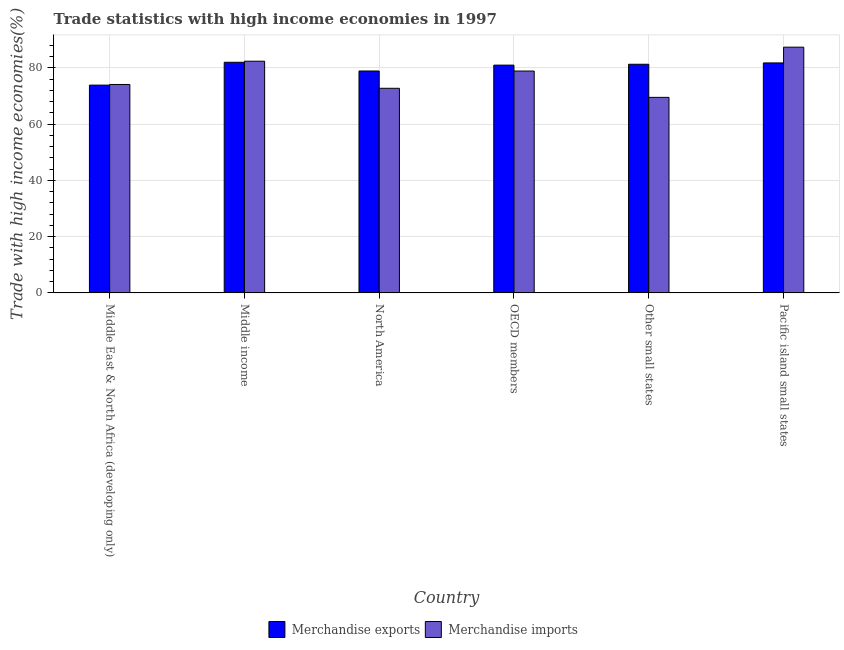Are the number of bars per tick equal to the number of legend labels?
Your answer should be compact. Yes. How many bars are there on the 1st tick from the left?
Provide a short and direct response. 2. How many bars are there on the 6th tick from the right?
Your answer should be compact. 2. What is the merchandise imports in Other small states?
Offer a very short reply. 69.51. Across all countries, what is the maximum merchandise imports?
Offer a very short reply. 87.36. Across all countries, what is the minimum merchandise exports?
Provide a succinct answer. 73.86. In which country was the merchandise imports minimum?
Your answer should be very brief. Other small states. What is the total merchandise imports in the graph?
Your answer should be very brief. 464.92. What is the difference between the merchandise exports in Middle East & North Africa (developing only) and that in Middle income?
Your answer should be very brief. -8.12. What is the difference between the merchandise exports in OECD members and the merchandise imports in Other small states?
Make the answer very short. 11.46. What is the average merchandise exports per country?
Offer a very short reply. 79.79. What is the difference between the merchandise exports and merchandise imports in Middle income?
Make the answer very short. -0.38. In how many countries, is the merchandise imports greater than 84 %?
Ensure brevity in your answer.  1. What is the ratio of the merchandise imports in Middle income to that in OECD members?
Keep it short and to the point. 1.04. Is the merchandise exports in North America less than that in Pacific island small states?
Keep it short and to the point. Yes. What is the difference between the highest and the second highest merchandise imports?
Your response must be concise. 4.99. What is the difference between the highest and the lowest merchandise exports?
Provide a succinct answer. 8.12. What does the 1st bar from the right in Other small states represents?
Provide a short and direct response. Merchandise imports. How many bars are there?
Offer a terse response. 12. Where does the legend appear in the graph?
Keep it short and to the point. Bottom center. How are the legend labels stacked?
Make the answer very short. Horizontal. What is the title of the graph?
Ensure brevity in your answer.  Trade statistics with high income economies in 1997. Does "From production" appear as one of the legend labels in the graph?
Provide a short and direct response. No. What is the label or title of the Y-axis?
Ensure brevity in your answer.  Trade with high income economies(%). What is the Trade with high income economies(%) of Merchandise exports in Middle East & North Africa (developing only)?
Give a very brief answer. 73.86. What is the Trade with high income economies(%) in Merchandise imports in Middle East & North Africa (developing only)?
Keep it short and to the point. 74.09. What is the Trade with high income economies(%) of Merchandise exports in Middle income?
Offer a very short reply. 81.99. What is the Trade with high income economies(%) in Merchandise imports in Middle income?
Make the answer very short. 82.36. What is the Trade with high income economies(%) of Merchandise exports in North America?
Give a very brief answer. 78.89. What is the Trade with high income economies(%) of Merchandise imports in North America?
Provide a short and direct response. 72.74. What is the Trade with high income economies(%) in Merchandise exports in OECD members?
Your response must be concise. 80.97. What is the Trade with high income economies(%) of Merchandise imports in OECD members?
Provide a succinct answer. 78.87. What is the Trade with high income economies(%) of Merchandise exports in Other small states?
Give a very brief answer. 81.28. What is the Trade with high income economies(%) of Merchandise imports in Other small states?
Your response must be concise. 69.51. What is the Trade with high income economies(%) in Merchandise exports in Pacific island small states?
Offer a terse response. 81.76. What is the Trade with high income economies(%) in Merchandise imports in Pacific island small states?
Make the answer very short. 87.36. Across all countries, what is the maximum Trade with high income economies(%) in Merchandise exports?
Ensure brevity in your answer.  81.99. Across all countries, what is the maximum Trade with high income economies(%) in Merchandise imports?
Your answer should be compact. 87.36. Across all countries, what is the minimum Trade with high income economies(%) in Merchandise exports?
Offer a terse response. 73.86. Across all countries, what is the minimum Trade with high income economies(%) in Merchandise imports?
Offer a terse response. 69.51. What is the total Trade with high income economies(%) of Merchandise exports in the graph?
Offer a terse response. 478.75. What is the total Trade with high income economies(%) of Merchandise imports in the graph?
Provide a short and direct response. 464.92. What is the difference between the Trade with high income economies(%) of Merchandise exports in Middle East & North Africa (developing only) and that in Middle income?
Give a very brief answer. -8.12. What is the difference between the Trade with high income economies(%) in Merchandise imports in Middle East & North Africa (developing only) and that in Middle income?
Keep it short and to the point. -8.27. What is the difference between the Trade with high income economies(%) of Merchandise exports in Middle East & North Africa (developing only) and that in North America?
Your response must be concise. -5.02. What is the difference between the Trade with high income economies(%) of Merchandise imports in Middle East & North Africa (developing only) and that in North America?
Your answer should be compact. 1.36. What is the difference between the Trade with high income economies(%) of Merchandise exports in Middle East & North Africa (developing only) and that in OECD members?
Ensure brevity in your answer.  -7.11. What is the difference between the Trade with high income economies(%) in Merchandise imports in Middle East & North Africa (developing only) and that in OECD members?
Keep it short and to the point. -4.77. What is the difference between the Trade with high income economies(%) in Merchandise exports in Middle East & North Africa (developing only) and that in Other small states?
Offer a very short reply. -7.42. What is the difference between the Trade with high income economies(%) in Merchandise imports in Middle East & North Africa (developing only) and that in Other small states?
Offer a terse response. 4.58. What is the difference between the Trade with high income economies(%) of Merchandise exports in Middle East & North Africa (developing only) and that in Pacific island small states?
Keep it short and to the point. -7.89. What is the difference between the Trade with high income economies(%) of Merchandise imports in Middle East & North Africa (developing only) and that in Pacific island small states?
Make the answer very short. -13.26. What is the difference between the Trade with high income economies(%) of Merchandise exports in Middle income and that in North America?
Provide a succinct answer. 3.1. What is the difference between the Trade with high income economies(%) in Merchandise imports in Middle income and that in North America?
Your response must be concise. 9.63. What is the difference between the Trade with high income economies(%) of Merchandise exports in Middle income and that in OECD members?
Give a very brief answer. 1.01. What is the difference between the Trade with high income economies(%) of Merchandise imports in Middle income and that in OECD members?
Ensure brevity in your answer.  3.49. What is the difference between the Trade with high income economies(%) in Merchandise exports in Middle income and that in Other small states?
Offer a very short reply. 0.7. What is the difference between the Trade with high income economies(%) of Merchandise imports in Middle income and that in Other small states?
Provide a short and direct response. 12.85. What is the difference between the Trade with high income economies(%) in Merchandise exports in Middle income and that in Pacific island small states?
Make the answer very short. 0.23. What is the difference between the Trade with high income economies(%) of Merchandise imports in Middle income and that in Pacific island small states?
Provide a short and direct response. -4.99. What is the difference between the Trade with high income economies(%) of Merchandise exports in North America and that in OECD members?
Provide a succinct answer. -2.08. What is the difference between the Trade with high income economies(%) in Merchandise imports in North America and that in OECD members?
Provide a short and direct response. -6.13. What is the difference between the Trade with high income economies(%) in Merchandise exports in North America and that in Other small states?
Your answer should be very brief. -2.4. What is the difference between the Trade with high income economies(%) in Merchandise imports in North America and that in Other small states?
Provide a short and direct response. 3.23. What is the difference between the Trade with high income economies(%) of Merchandise exports in North America and that in Pacific island small states?
Give a very brief answer. -2.87. What is the difference between the Trade with high income economies(%) of Merchandise imports in North America and that in Pacific island small states?
Give a very brief answer. -14.62. What is the difference between the Trade with high income economies(%) in Merchandise exports in OECD members and that in Other small states?
Keep it short and to the point. -0.31. What is the difference between the Trade with high income economies(%) of Merchandise imports in OECD members and that in Other small states?
Your response must be concise. 9.36. What is the difference between the Trade with high income economies(%) in Merchandise exports in OECD members and that in Pacific island small states?
Your answer should be compact. -0.79. What is the difference between the Trade with high income economies(%) in Merchandise imports in OECD members and that in Pacific island small states?
Your answer should be very brief. -8.49. What is the difference between the Trade with high income economies(%) in Merchandise exports in Other small states and that in Pacific island small states?
Offer a very short reply. -0.47. What is the difference between the Trade with high income economies(%) in Merchandise imports in Other small states and that in Pacific island small states?
Give a very brief answer. -17.84. What is the difference between the Trade with high income economies(%) of Merchandise exports in Middle East & North Africa (developing only) and the Trade with high income economies(%) of Merchandise imports in Middle income?
Give a very brief answer. -8.5. What is the difference between the Trade with high income economies(%) in Merchandise exports in Middle East & North Africa (developing only) and the Trade with high income economies(%) in Merchandise imports in North America?
Provide a short and direct response. 1.13. What is the difference between the Trade with high income economies(%) in Merchandise exports in Middle East & North Africa (developing only) and the Trade with high income economies(%) in Merchandise imports in OECD members?
Your answer should be very brief. -5. What is the difference between the Trade with high income economies(%) in Merchandise exports in Middle East & North Africa (developing only) and the Trade with high income economies(%) in Merchandise imports in Other small states?
Offer a very short reply. 4.35. What is the difference between the Trade with high income economies(%) of Merchandise exports in Middle East & North Africa (developing only) and the Trade with high income economies(%) of Merchandise imports in Pacific island small states?
Keep it short and to the point. -13.49. What is the difference between the Trade with high income economies(%) in Merchandise exports in Middle income and the Trade with high income economies(%) in Merchandise imports in North America?
Your answer should be compact. 9.25. What is the difference between the Trade with high income economies(%) of Merchandise exports in Middle income and the Trade with high income economies(%) of Merchandise imports in OECD members?
Make the answer very short. 3.12. What is the difference between the Trade with high income economies(%) in Merchandise exports in Middle income and the Trade with high income economies(%) in Merchandise imports in Other small states?
Provide a short and direct response. 12.48. What is the difference between the Trade with high income economies(%) in Merchandise exports in Middle income and the Trade with high income economies(%) in Merchandise imports in Pacific island small states?
Give a very brief answer. -5.37. What is the difference between the Trade with high income economies(%) of Merchandise exports in North America and the Trade with high income economies(%) of Merchandise imports in OECD members?
Your answer should be very brief. 0.02. What is the difference between the Trade with high income economies(%) in Merchandise exports in North America and the Trade with high income economies(%) in Merchandise imports in Other small states?
Provide a short and direct response. 9.38. What is the difference between the Trade with high income economies(%) of Merchandise exports in North America and the Trade with high income economies(%) of Merchandise imports in Pacific island small states?
Provide a short and direct response. -8.47. What is the difference between the Trade with high income economies(%) in Merchandise exports in OECD members and the Trade with high income economies(%) in Merchandise imports in Other small states?
Your answer should be very brief. 11.46. What is the difference between the Trade with high income economies(%) of Merchandise exports in OECD members and the Trade with high income economies(%) of Merchandise imports in Pacific island small states?
Offer a very short reply. -6.38. What is the difference between the Trade with high income economies(%) of Merchandise exports in Other small states and the Trade with high income economies(%) of Merchandise imports in Pacific island small states?
Your answer should be very brief. -6.07. What is the average Trade with high income economies(%) of Merchandise exports per country?
Provide a short and direct response. 79.79. What is the average Trade with high income economies(%) of Merchandise imports per country?
Keep it short and to the point. 77.49. What is the difference between the Trade with high income economies(%) of Merchandise exports and Trade with high income economies(%) of Merchandise imports in Middle East & North Africa (developing only)?
Provide a succinct answer. -0.23. What is the difference between the Trade with high income economies(%) in Merchandise exports and Trade with high income economies(%) in Merchandise imports in Middle income?
Make the answer very short. -0.38. What is the difference between the Trade with high income economies(%) in Merchandise exports and Trade with high income economies(%) in Merchandise imports in North America?
Give a very brief answer. 6.15. What is the difference between the Trade with high income economies(%) of Merchandise exports and Trade with high income economies(%) of Merchandise imports in OECD members?
Give a very brief answer. 2.1. What is the difference between the Trade with high income economies(%) in Merchandise exports and Trade with high income economies(%) in Merchandise imports in Other small states?
Offer a very short reply. 11.77. What is the difference between the Trade with high income economies(%) of Merchandise exports and Trade with high income economies(%) of Merchandise imports in Pacific island small states?
Provide a succinct answer. -5.6. What is the ratio of the Trade with high income economies(%) in Merchandise exports in Middle East & North Africa (developing only) to that in Middle income?
Offer a terse response. 0.9. What is the ratio of the Trade with high income economies(%) of Merchandise imports in Middle East & North Africa (developing only) to that in Middle income?
Your response must be concise. 0.9. What is the ratio of the Trade with high income economies(%) of Merchandise exports in Middle East & North Africa (developing only) to that in North America?
Give a very brief answer. 0.94. What is the ratio of the Trade with high income economies(%) of Merchandise imports in Middle East & North Africa (developing only) to that in North America?
Make the answer very short. 1.02. What is the ratio of the Trade with high income economies(%) of Merchandise exports in Middle East & North Africa (developing only) to that in OECD members?
Keep it short and to the point. 0.91. What is the ratio of the Trade with high income economies(%) of Merchandise imports in Middle East & North Africa (developing only) to that in OECD members?
Offer a very short reply. 0.94. What is the ratio of the Trade with high income economies(%) of Merchandise exports in Middle East & North Africa (developing only) to that in Other small states?
Make the answer very short. 0.91. What is the ratio of the Trade with high income economies(%) of Merchandise imports in Middle East & North Africa (developing only) to that in Other small states?
Provide a succinct answer. 1.07. What is the ratio of the Trade with high income economies(%) in Merchandise exports in Middle East & North Africa (developing only) to that in Pacific island small states?
Make the answer very short. 0.9. What is the ratio of the Trade with high income economies(%) of Merchandise imports in Middle East & North Africa (developing only) to that in Pacific island small states?
Make the answer very short. 0.85. What is the ratio of the Trade with high income economies(%) of Merchandise exports in Middle income to that in North America?
Provide a succinct answer. 1.04. What is the ratio of the Trade with high income economies(%) in Merchandise imports in Middle income to that in North America?
Offer a terse response. 1.13. What is the ratio of the Trade with high income economies(%) in Merchandise exports in Middle income to that in OECD members?
Your answer should be compact. 1.01. What is the ratio of the Trade with high income economies(%) in Merchandise imports in Middle income to that in OECD members?
Keep it short and to the point. 1.04. What is the ratio of the Trade with high income economies(%) of Merchandise exports in Middle income to that in Other small states?
Your answer should be very brief. 1.01. What is the ratio of the Trade with high income economies(%) of Merchandise imports in Middle income to that in Other small states?
Ensure brevity in your answer.  1.18. What is the ratio of the Trade with high income economies(%) in Merchandise exports in Middle income to that in Pacific island small states?
Make the answer very short. 1. What is the ratio of the Trade with high income economies(%) of Merchandise imports in Middle income to that in Pacific island small states?
Your answer should be very brief. 0.94. What is the ratio of the Trade with high income economies(%) of Merchandise exports in North America to that in OECD members?
Offer a terse response. 0.97. What is the ratio of the Trade with high income economies(%) of Merchandise imports in North America to that in OECD members?
Make the answer very short. 0.92. What is the ratio of the Trade with high income economies(%) of Merchandise exports in North America to that in Other small states?
Offer a very short reply. 0.97. What is the ratio of the Trade with high income economies(%) in Merchandise imports in North America to that in Other small states?
Offer a terse response. 1.05. What is the ratio of the Trade with high income economies(%) in Merchandise exports in North America to that in Pacific island small states?
Ensure brevity in your answer.  0.96. What is the ratio of the Trade with high income economies(%) of Merchandise imports in North America to that in Pacific island small states?
Your answer should be compact. 0.83. What is the ratio of the Trade with high income economies(%) in Merchandise exports in OECD members to that in Other small states?
Provide a succinct answer. 1. What is the ratio of the Trade with high income economies(%) of Merchandise imports in OECD members to that in Other small states?
Provide a short and direct response. 1.13. What is the ratio of the Trade with high income economies(%) in Merchandise exports in OECD members to that in Pacific island small states?
Ensure brevity in your answer.  0.99. What is the ratio of the Trade with high income economies(%) in Merchandise imports in OECD members to that in Pacific island small states?
Ensure brevity in your answer.  0.9. What is the ratio of the Trade with high income economies(%) of Merchandise imports in Other small states to that in Pacific island small states?
Provide a short and direct response. 0.8. What is the difference between the highest and the second highest Trade with high income economies(%) in Merchandise exports?
Offer a very short reply. 0.23. What is the difference between the highest and the second highest Trade with high income economies(%) in Merchandise imports?
Your response must be concise. 4.99. What is the difference between the highest and the lowest Trade with high income economies(%) of Merchandise exports?
Keep it short and to the point. 8.12. What is the difference between the highest and the lowest Trade with high income economies(%) of Merchandise imports?
Offer a very short reply. 17.84. 